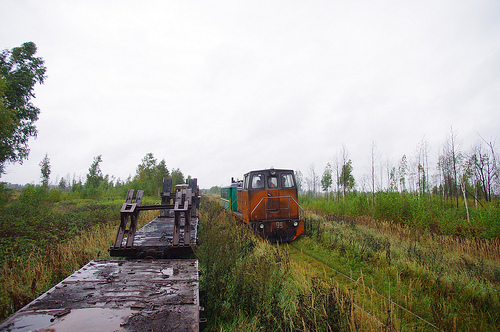How many trains on the train tracks? There is one train visible on the tracks, settled amidst a grassy and somewhat wet landscape with overcast skies hinting at recent or impending rain. 